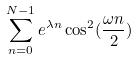<formula> <loc_0><loc_0><loc_500><loc_500>\sum _ { n = 0 } ^ { N - 1 } e ^ { \lambda n } \cos ^ { 2 } ( \frac { \omega n } { 2 } )</formula> 